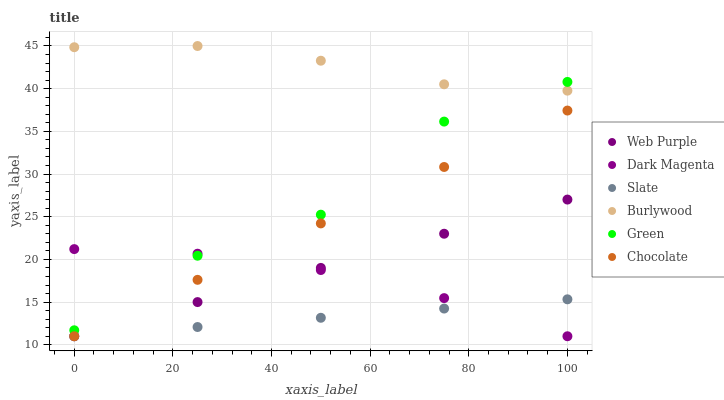Does Slate have the minimum area under the curve?
Answer yes or no. Yes. Does Burlywood have the maximum area under the curve?
Answer yes or no. Yes. Does Burlywood have the minimum area under the curve?
Answer yes or no. No. Does Slate have the maximum area under the curve?
Answer yes or no. No. Is Chocolate the smoothest?
Answer yes or no. Yes. Is Green the roughest?
Answer yes or no. Yes. Is Burlywood the smoothest?
Answer yes or no. No. Is Burlywood the roughest?
Answer yes or no. No. Does Dark Magenta have the lowest value?
Answer yes or no. Yes. Does Burlywood have the lowest value?
Answer yes or no. No. Does Burlywood have the highest value?
Answer yes or no. Yes. Does Slate have the highest value?
Answer yes or no. No. Is Chocolate less than Green?
Answer yes or no. Yes. Is Burlywood greater than Slate?
Answer yes or no. Yes. Does Green intersect Burlywood?
Answer yes or no. Yes. Is Green less than Burlywood?
Answer yes or no. No. Is Green greater than Burlywood?
Answer yes or no. No. Does Chocolate intersect Green?
Answer yes or no. No. 